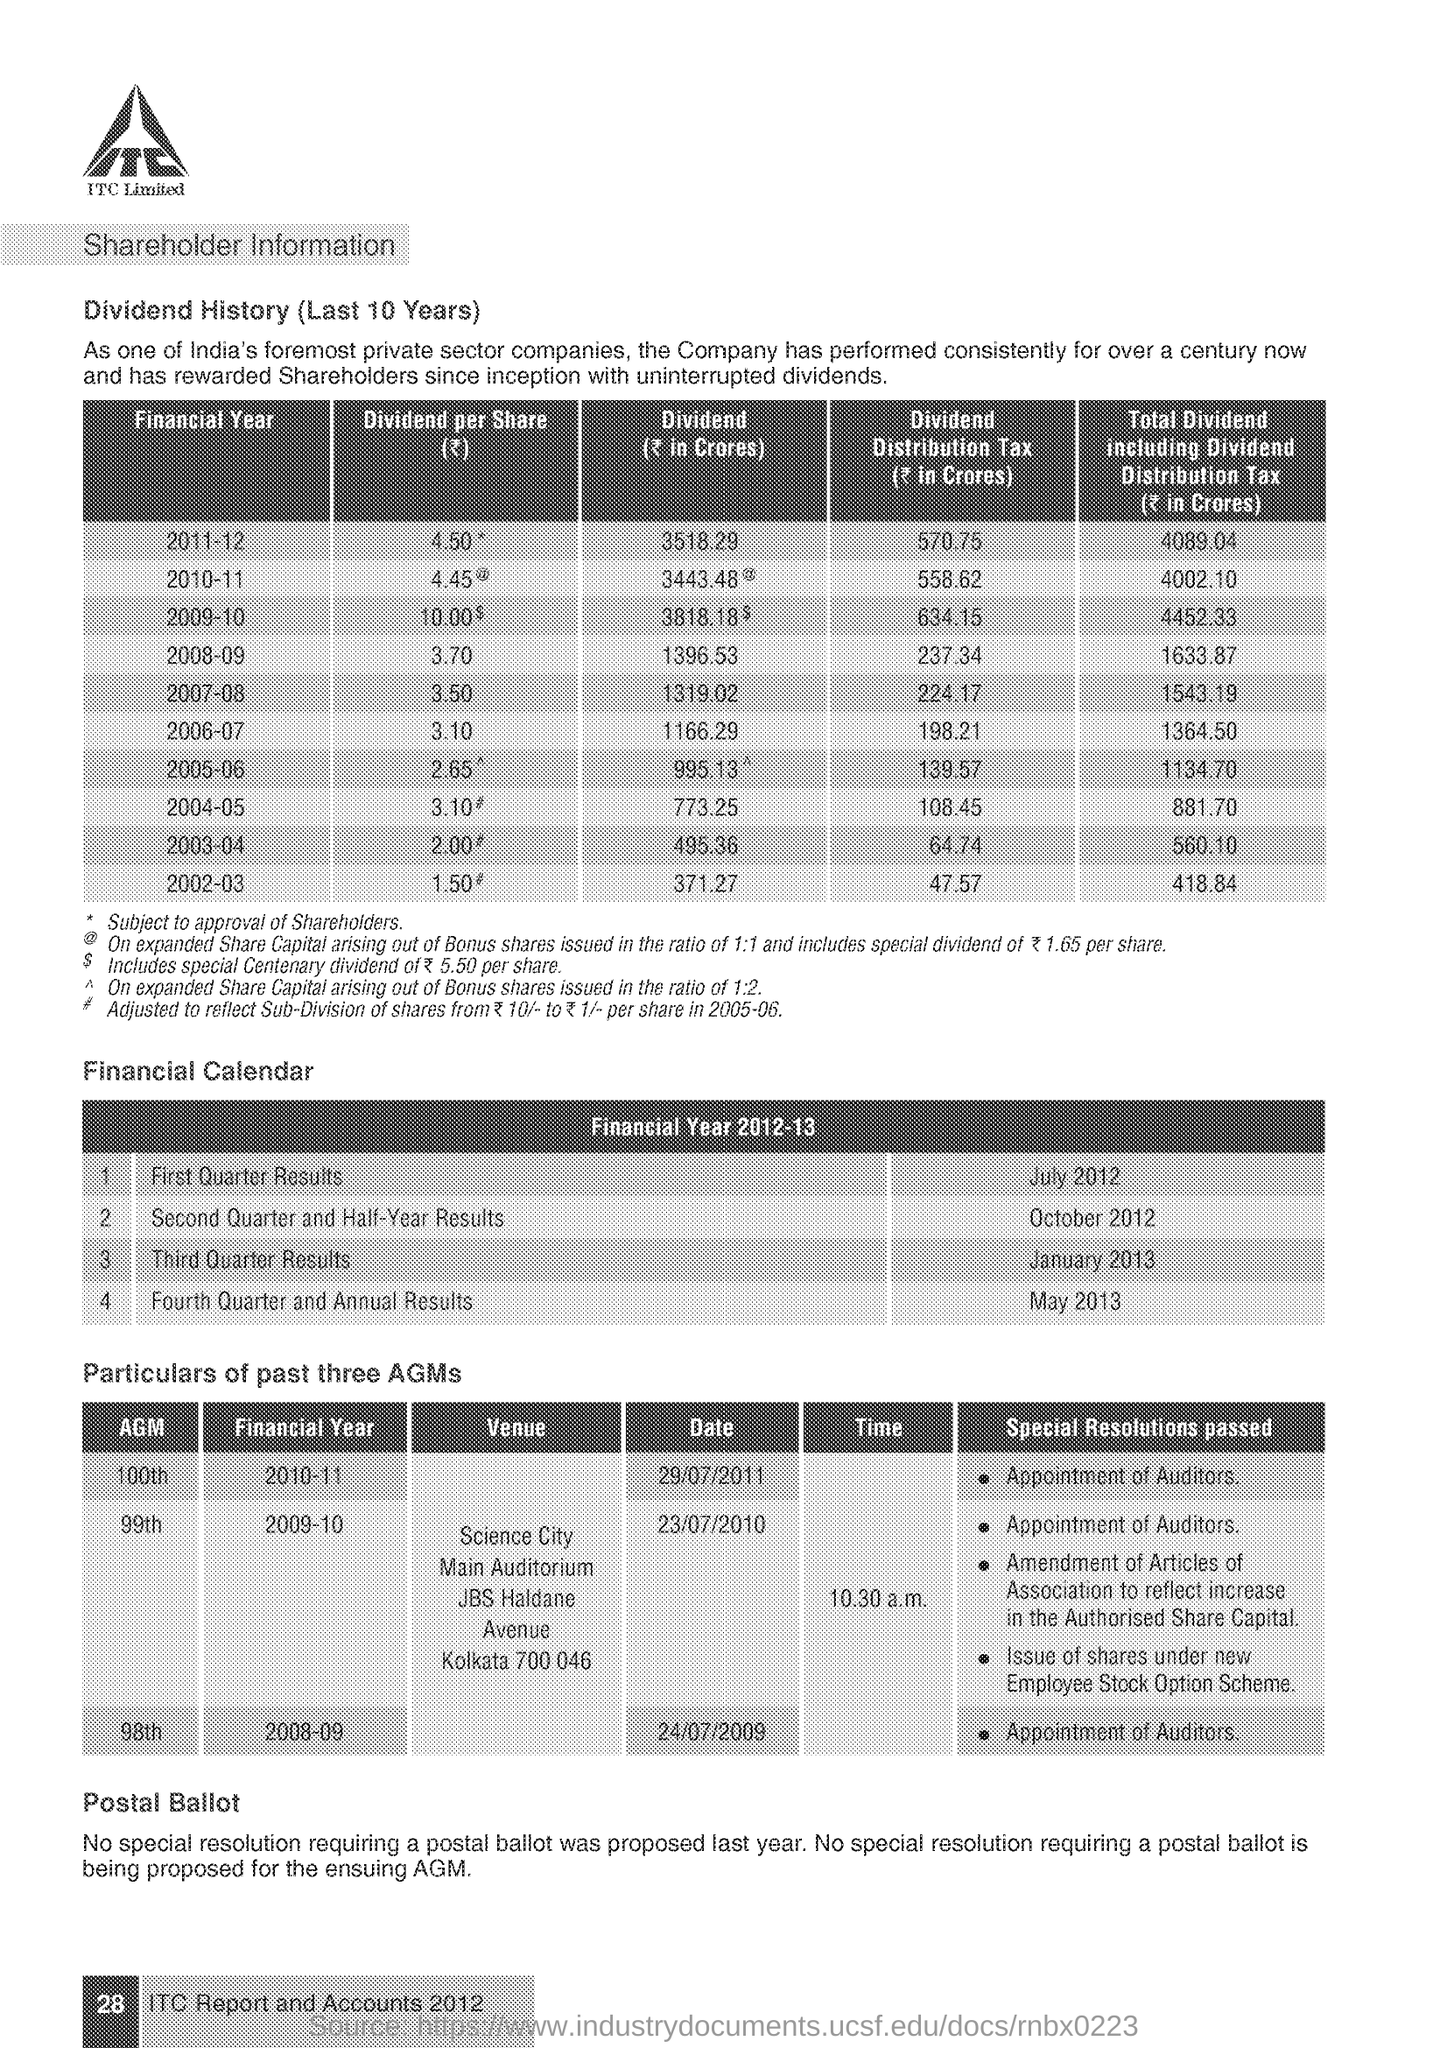Indicate a few pertinent items in this graphic. During the financial year calendar, the first quarter results are scheduled to be released in the month of July 2012. 